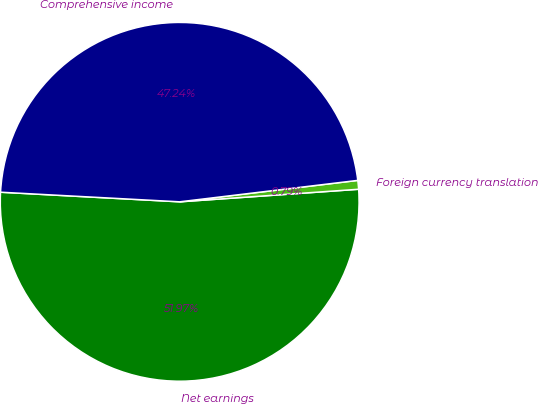Convert chart to OTSL. <chart><loc_0><loc_0><loc_500><loc_500><pie_chart><fcel>Net earnings<fcel>Foreign currency translation<fcel>Comprehensive income<nl><fcel>51.97%<fcel>0.79%<fcel>47.24%<nl></chart> 